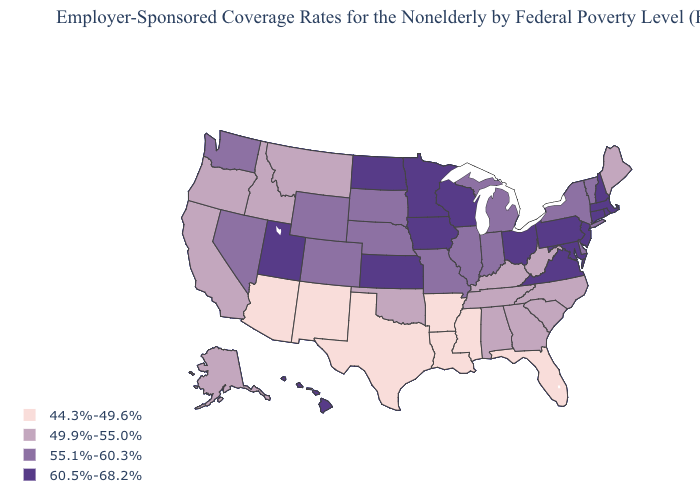Does Indiana have a higher value than Iowa?
Concise answer only. No. What is the highest value in states that border California?
Be succinct. 55.1%-60.3%. Name the states that have a value in the range 44.3%-49.6%?
Quick response, please. Arizona, Arkansas, Florida, Louisiana, Mississippi, New Mexico, Texas. What is the value of Montana?
Be succinct. 49.9%-55.0%. What is the lowest value in the Northeast?
Write a very short answer. 49.9%-55.0%. Among the states that border South Dakota , does Iowa have the highest value?
Concise answer only. Yes. Name the states that have a value in the range 44.3%-49.6%?
Short answer required. Arizona, Arkansas, Florida, Louisiana, Mississippi, New Mexico, Texas. Which states hav the highest value in the South?
Be succinct. Maryland, Virginia. Name the states that have a value in the range 55.1%-60.3%?
Give a very brief answer. Colorado, Delaware, Illinois, Indiana, Michigan, Missouri, Nebraska, Nevada, New York, South Dakota, Vermont, Washington, Wyoming. Does the first symbol in the legend represent the smallest category?
Be succinct. Yes. Name the states that have a value in the range 49.9%-55.0%?
Concise answer only. Alabama, Alaska, California, Georgia, Idaho, Kentucky, Maine, Montana, North Carolina, Oklahoma, Oregon, South Carolina, Tennessee, West Virginia. What is the value of Wisconsin?
Quick response, please. 60.5%-68.2%. What is the value of North Dakota?
Be succinct. 60.5%-68.2%. Which states have the lowest value in the MidWest?
Quick response, please. Illinois, Indiana, Michigan, Missouri, Nebraska, South Dakota. Which states hav the highest value in the South?
Be succinct. Maryland, Virginia. 